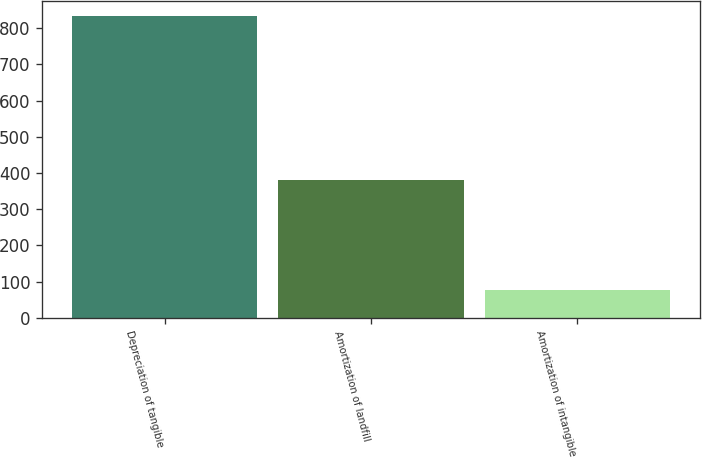<chart> <loc_0><loc_0><loc_500><loc_500><bar_chart><fcel>Depreciation of tangible<fcel>Amortization of landfill<fcel>Amortization of intangible<nl><fcel>834<fcel>380<fcel>78<nl></chart> 